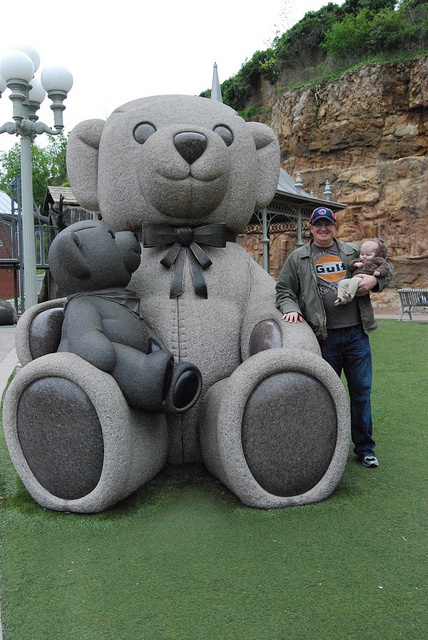Describe the objects in this image and their specific colors. I can see teddy bear in white, gray, darkgray, and black tones, people in white, black, gray, darkgray, and navy tones, and bench in white, gray, darkgray, and black tones in this image. 